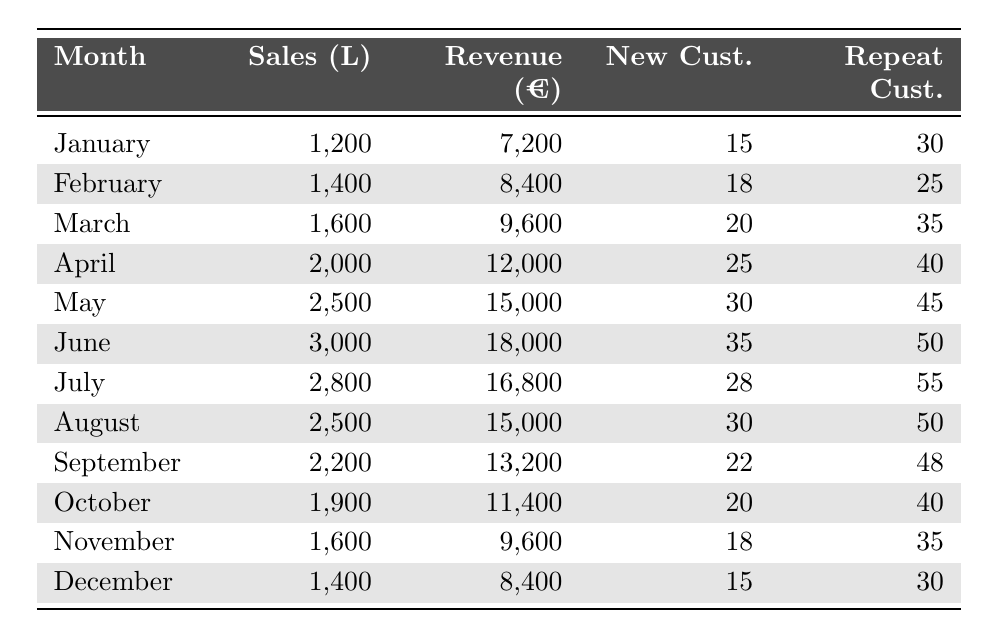What is the total sales volume of olive oil in May? From the table, the sales volume for May is directly stated as 2,500 liters.
Answer: 2,500 liters What was the revenue in June? The table indicates that the revenue for June is 18,000 euros.
Answer: 18,000 euros How many new customers were there in March? The entry for March in the table shows there were 20 new customers.
Answer: 20 new customers Which month had the highest total sales volume? By comparing all the values in the sales volume column, June, with 3,000 liters, has the highest value.
Answer: June What is the total revenue from January to April? The revenue for each month from January to April is: January (7,200) + February (8,400) + March (9,600) + April (12,000) = 37,200 euros.
Answer: 37,200 euros How many repeat customers were there in August compared to July? In August, there were 50 repeat customers, while in July there were 55. This shows August had 5 fewer repeat customers than July.
Answer: 5 fewer customers True or False: The number of new customers in April is less than in February. The new customers in April is 25, while in February it’s 18, therefore the statement is false.
Answer: False What was the average number of new customers per month across the year? To find the average, sum all new customers: (15 + 18 + 20 + 25 + 30 + 35 + 28 + 30 + 22 + 20 + 18 + 15) =  300. Then divide by 12 months: 300 / 12 = 25.
Answer: 25 In which month did revenue exceed 15,000 euros? By scanning the revenue column, it can be seen that revenue exceeded 15,000 euros in May (15,000) and June (18,000).
Answer: May and June How much was the decrease in total sales volume from June to October? The total sales volume in June is 3,000 liters, and in October, it is 1,900 liters. The decrease is calculated as 3,000 - 1,900 = 1,100 liters.
Answer: 1,100 liters 